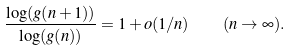Convert formula to latex. <formula><loc_0><loc_0><loc_500><loc_500>\frac { \log ( g ( n + 1 ) ) } { \log ( g ( n ) ) } = 1 + o ( 1 / n ) \quad ( n \to \infty ) .</formula> 